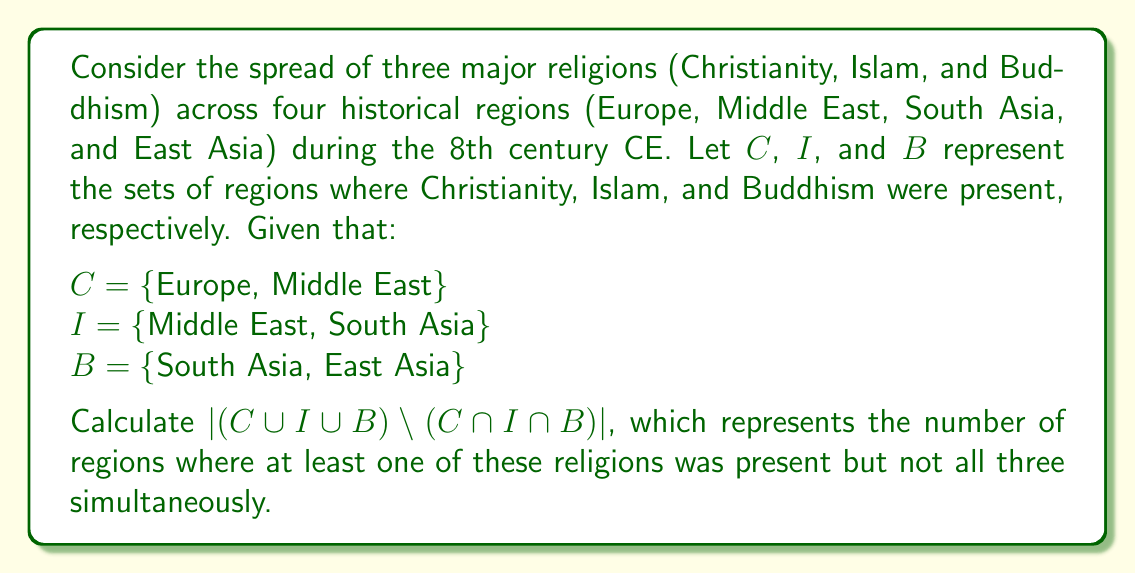Help me with this question. To solve this problem, we'll follow these steps:

1) First, let's identify $C \cup I \cup B$:
   This is the set of all regions where at least one of the religions was present.
   $C \cup I \cup B = \{Europe, Middle East, South Asia, East Asia\}$

2) Next, let's find $C \cap I \cap B$:
   This is the set of regions where all three religions were present simultaneously.
   $C \cap I \cap B = \{\}$ (empty set)

3) Now, we need to calculate $(C \cup I \cup B) \setminus (C \cap I \cap B)$:
   Since $C \cap I \cap B$ is empty, this operation is equivalent to just $C \cup I \cup B$.

4) Finally, we need to find the cardinality of this set:
   $|(C \cup I \cup B) \setminus (C \cap I \cap B)| = |C \cup I \cup B| = |\{Europe, Middle East, South Asia, East Asia\}| = 4$

This result shows that in the 8th century CE, these three major religions had spread to all four historical regions considered, but there was no region where all three were simultaneously present.
Answer: 4 